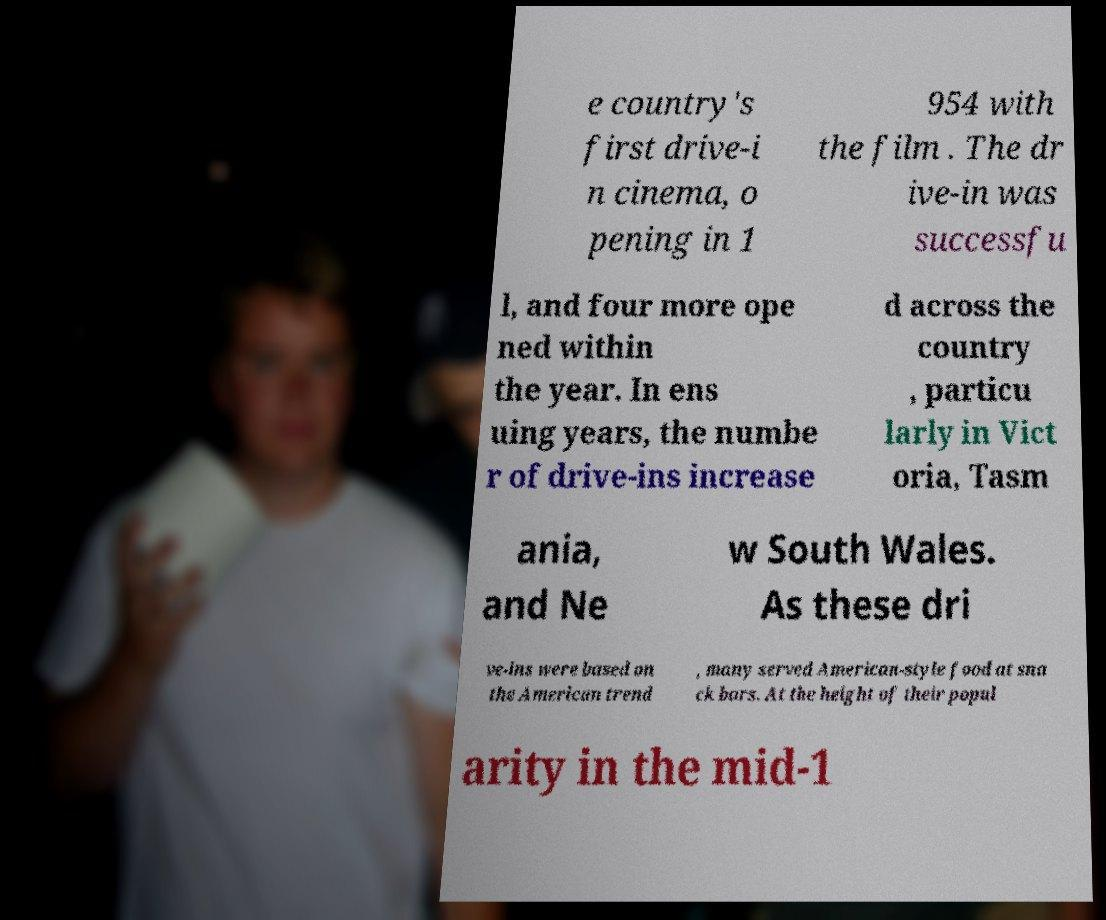Could you extract and type out the text from this image? e country's first drive-i n cinema, o pening in 1 954 with the film . The dr ive-in was successfu l, and four more ope ned within the year. In ens uing years, the numbe r of drive-ins increase d across the country , particu larly in Vict oria, Tasm ania, and Ne w South Wales. As these dri ve-ins were based on the American trend , many served American-style food at sna ck bars. At the height of their popul arity in the mid-1 